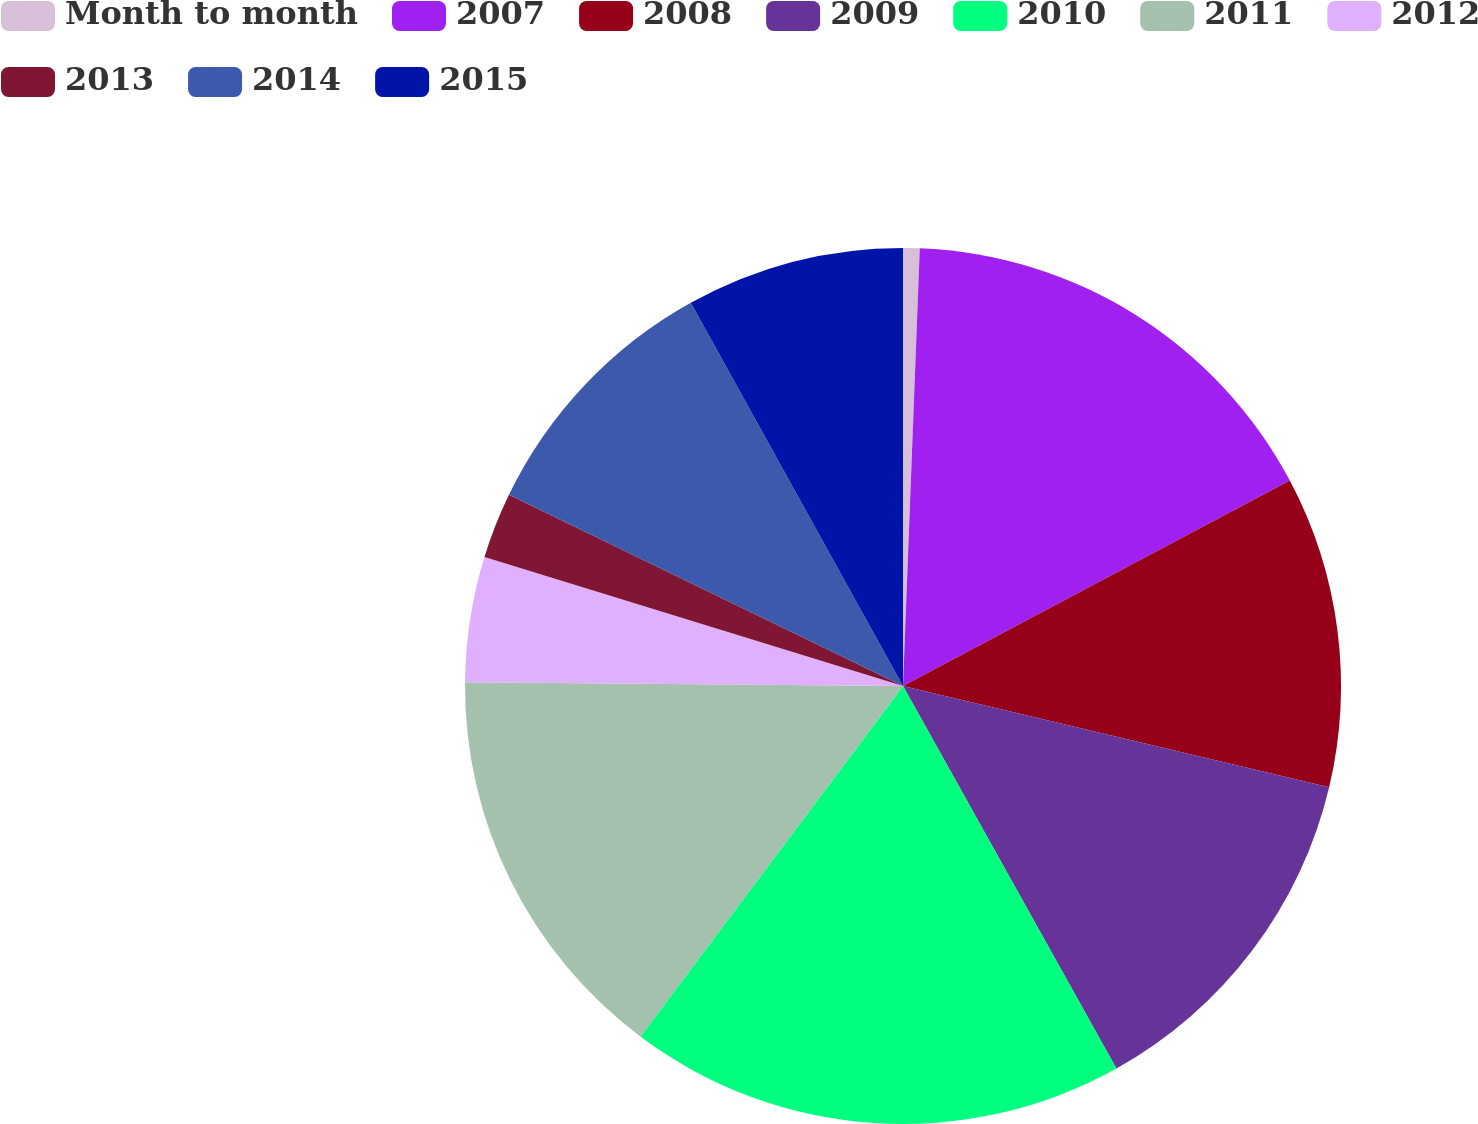<chart> <loc_0><loc_0><loc_500><loc_500><pie_chart><fcel>Month to month<fcel>2007<fcel>2008<fcel>2009<fcel>2010<fcel>2011<fcel>2012<fcel>2013<fcel>2014<fcel>2015<nl><fcel>0.61%<fcel>16.62%<fcel>11.48%<fcel>13.19%<fcel>18.33%<fcel>14.91%<fcel>4.62%<fcel>2.43%<fcel>9.76%<fcel>8.05%<nl></chart> 